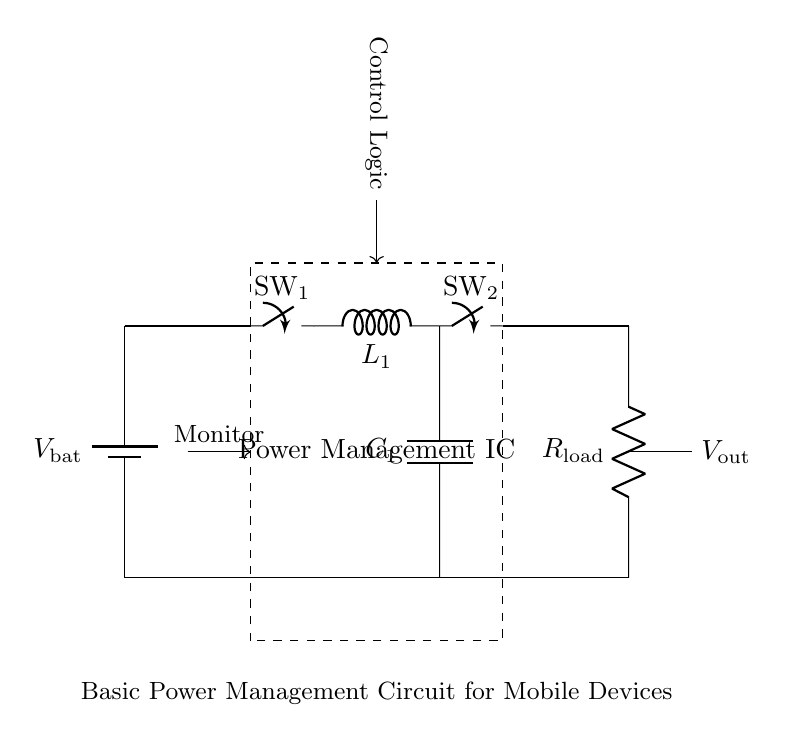What type of converter is used in this circuit? The circuit includes a buck converter, which is used to step down voltage from the battery to an appropriate level for the load. This is indicated by the specific components labeled as the buck converter's switch and inductor.
Answer: Buck converter What does "C1" represent in the circuit? "C1" denotes a capacitor in the circuit. Capacitors are typically used for energy storage and smoothing voltage variations. Its labeling and placement in the circuit further confirm its role.
Answer: Capacitor How many switches are present in this circuit? There are two switches in the circuit diagram as labeled "SW1" and "SW2." Their distinct positions and labels indicate they control different segments of the circuit.
Answer: Two What is the function of the Power Management IC? The Power Management IC coordinates and optimizes the distribution of power within the circuit, ensuring efficient battery usage and managing power flow to the load. Its enclosure in a dashed rectangle signifies it as a separate functional unit.
Answer: Power distribution What is the purpose of the "R_load" component? "R_load" identifies the load resistor in the circuit. It represents the component where the output voltage is delivered and helps define the load's power consumption. It is positioned as the endpoint of the circuit for the output.
Answer: Load resistor What is the output voltage generated by this circuit? The output voltage, labeled as "V_out," is taken from the connection point to "R_load". This output will be the voltage available to power the connected device, usually at a lower level than the input from the battery.
Answer: V_out What does the "Control Logic" component do? The "Control Logic" is responsible for regulating the operation of the buck converter and controlling the switching mechanisms based on the battery's status and load requirements, ensuring efficient power management. It is placed above the main components to indicate its overseeing role.
Answer: Regulation 